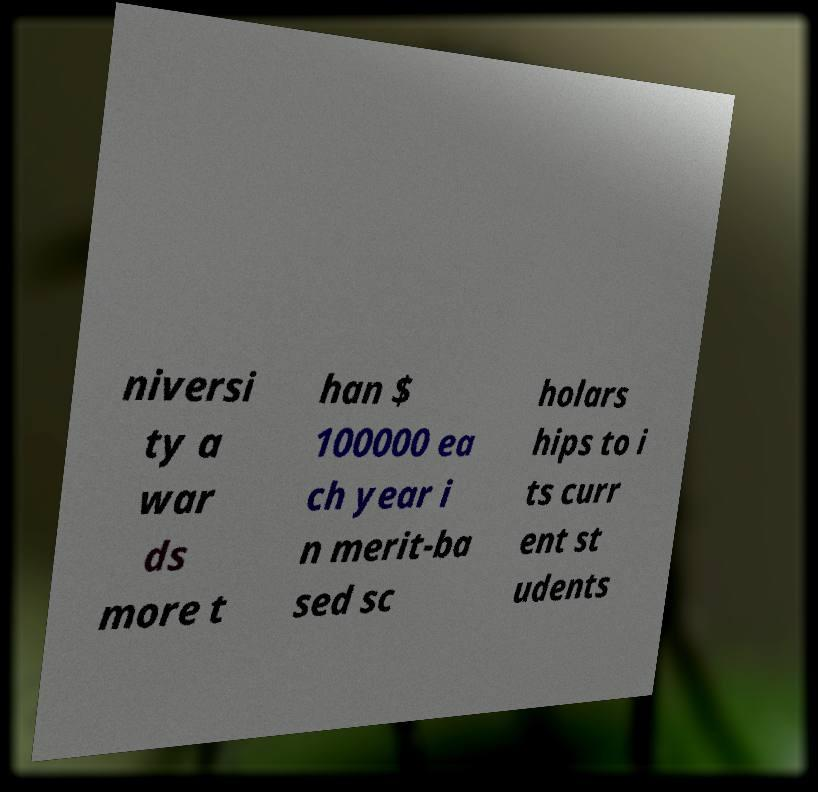Can you read and provide the text displayed in the image?This photo seems to have some interesting text. Can you extract and type it out for me? niversi ty a war ds more t han $ 100000 ea ch year i n merit-ba sed sc holars hips to i ts curr ent st udents 